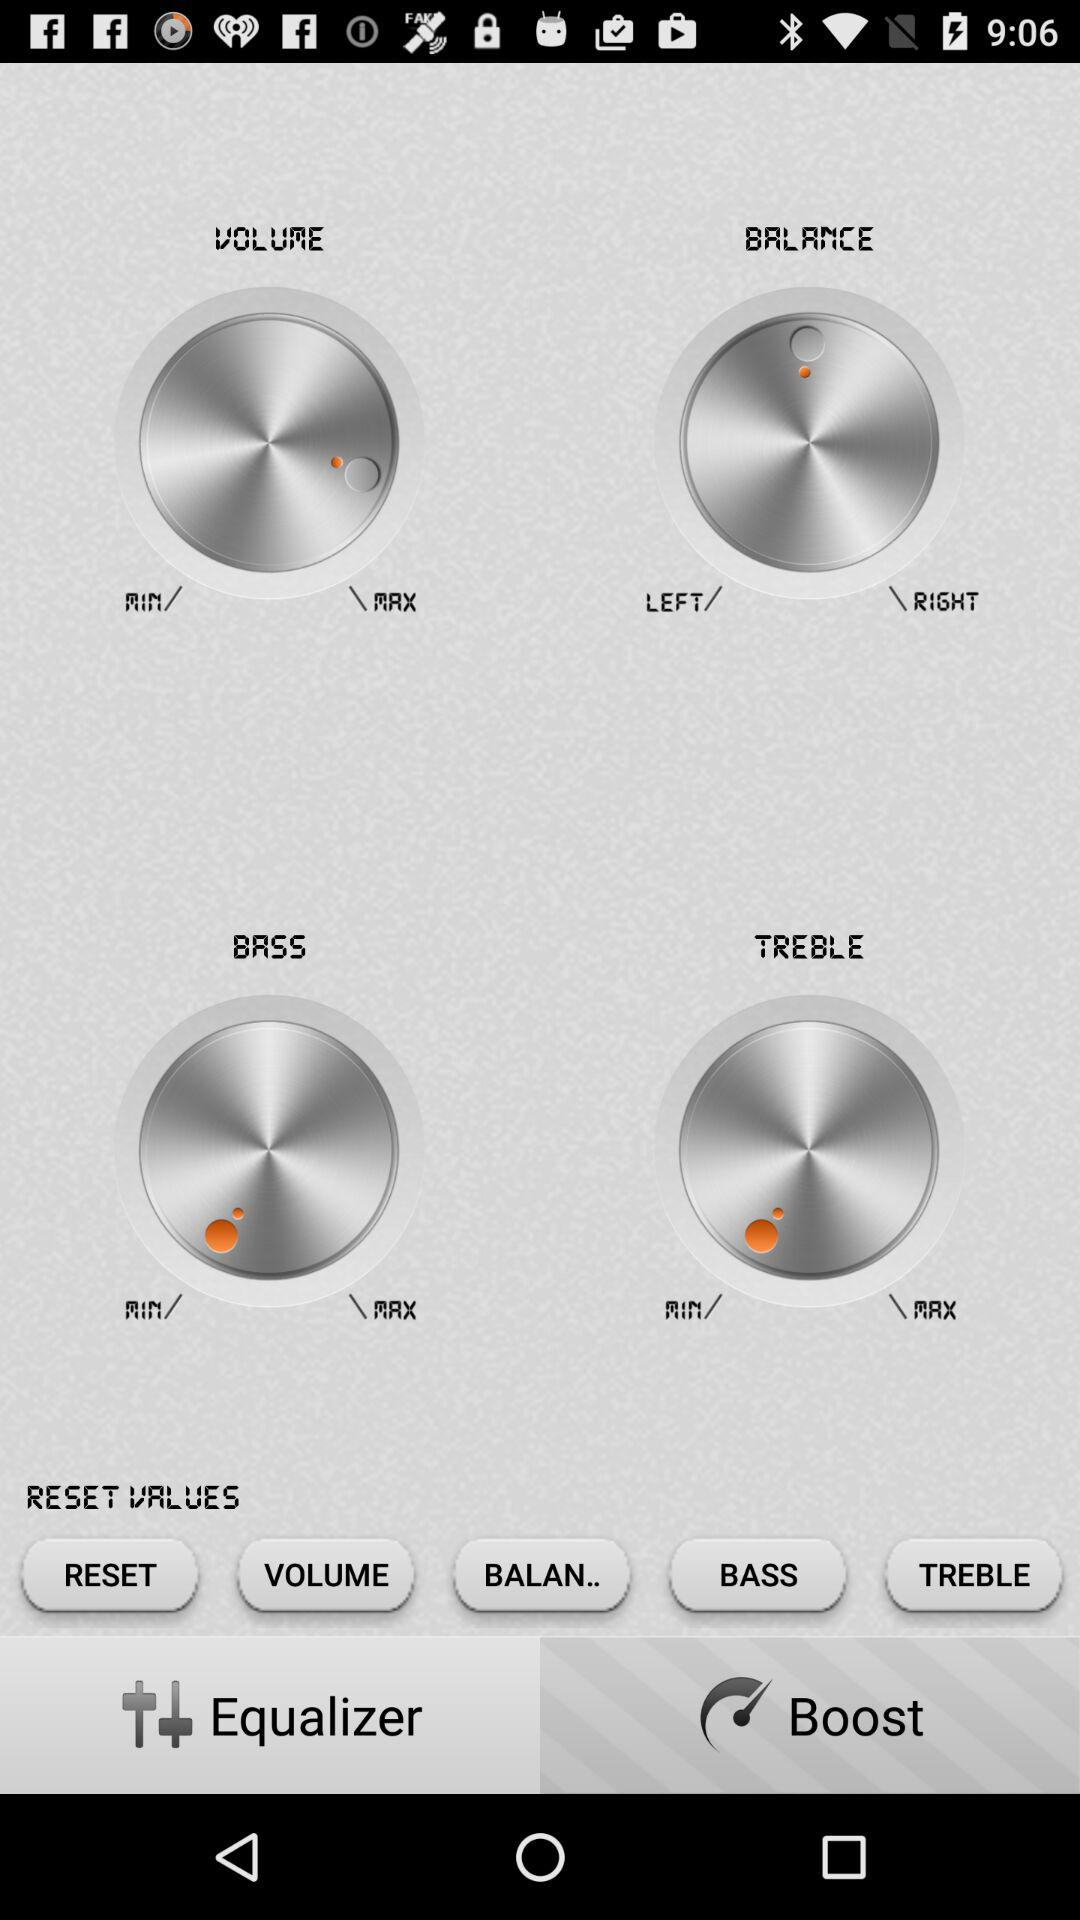Which tab is selected? The selected tab is "Equalizer". 